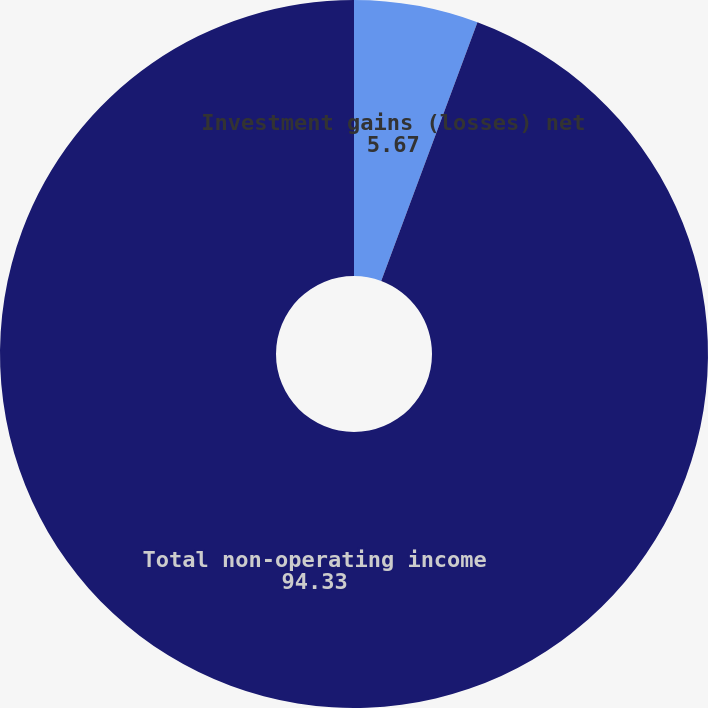Convert chart to OTSL. <chart><loc_0><loc_0><loc_500><loc_500><pie_chart><fcel>Investment gains (losses) net<fcel>Total non-operating income<nl><fcel>5.67%<fcel>94.33%<nl></chart> 